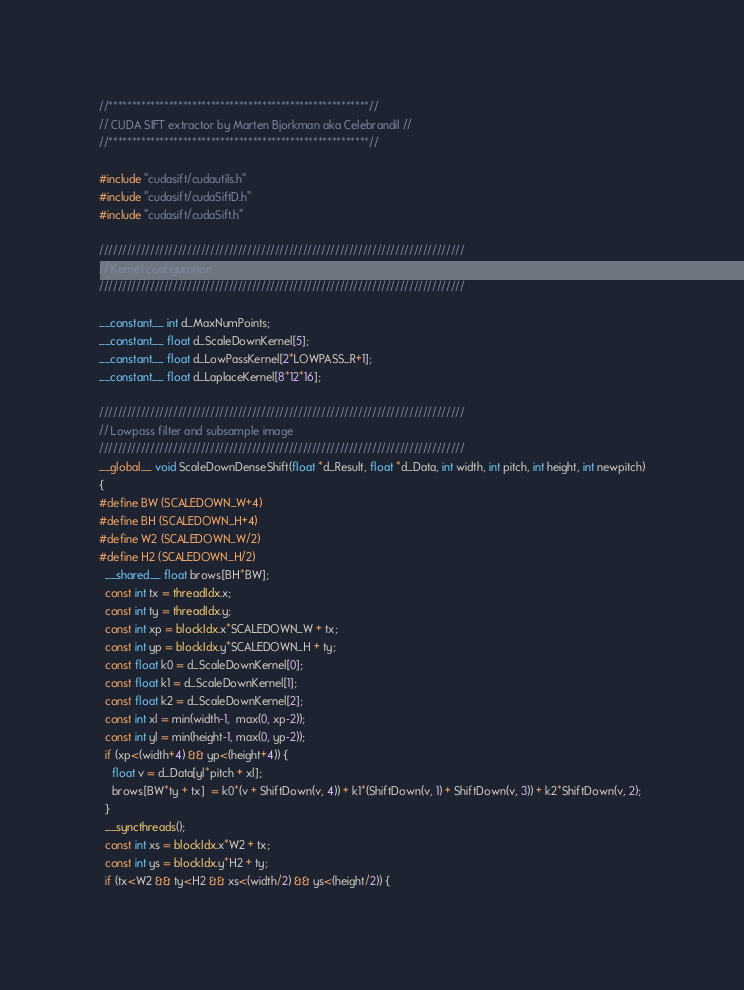Convert code to text. <code><loc_0><loc_0><loc_500><loc_500><_Cuda_>//********************************************************//
// CUDA SIFT extractor by Marten Bjorkman aka Celebrandil //
//********************************************************//  

#include "cudasift/cudautils.h"
#include "cudasift/cudaSiftD.h"
#include "cudasift/cudaSift.h"

///////////////////////////////////////////////////////////////////////////////
// Kernel configuration
///////////////////////////////////////////////////////////////////////////////

__constant__ int d_MaxNumPoints;
__constant__ float d_ScaleDownKernel[5];
__constant__ float d_LowPassKernel[2*LOWPASS_R+1]; 
__constant__ float d_LaplaceKernel[8*12*16]; 

///////////////////////////////////////////////////////////////////////////////
// Lowpass filter and subsample image
///////////////////////////////////////////////////////////////////////////////
__global__ void ScaleDownDenseShift(float *d_Result, float *d_Data, int width, int pitch, int height, int newpitch)
{
#define BW (SCALEDOWN_W+4)
#define BH (SCALEDOWN_H+4)
#define W2 (SCALEDOWN_W/2)
#define H2 (SCALEDOWN_H/2)
  __shared__ float brows[BH*BW];
  const int tx = threadIdx.x;
  const int ty = threadIdx.y;
  const int xp = blockIdx.x*SCALEDOWN_W + tx;
  const int yp = blockIdx.y*SCALEDOWN_H + ty;
  const float k0 = d_ScaleDownKernel[0];
  const float k1 = d_ScaleDownKernel[1];
  const float k2 = d_ScaleDownKernel[2];
  const int xl = min(width-1,  max(0, xp-2));
  const int yl = min(height-1, max(0, yp-2));
  if (xp<(width+4) && yp<(height+4)) {
    float v = d_Data[yl*pitch + xl];
    brows[BW*ty + tx]  = k0*(v + ShiftDown(v, 4)) + k1*(ShiftDown(v, 1) + ShiftDown(v, 3)) + k2*ShiftDown(v, 2);
  }
  __syncthreads();
  const int xs = blockIdx.x*W2 + tx;
  const int ys = blockIdx.y*H2 + ty;
  if (tx<W2 && ty<H2 && xs<(width/2) && ys<(height/2)) {</code> 